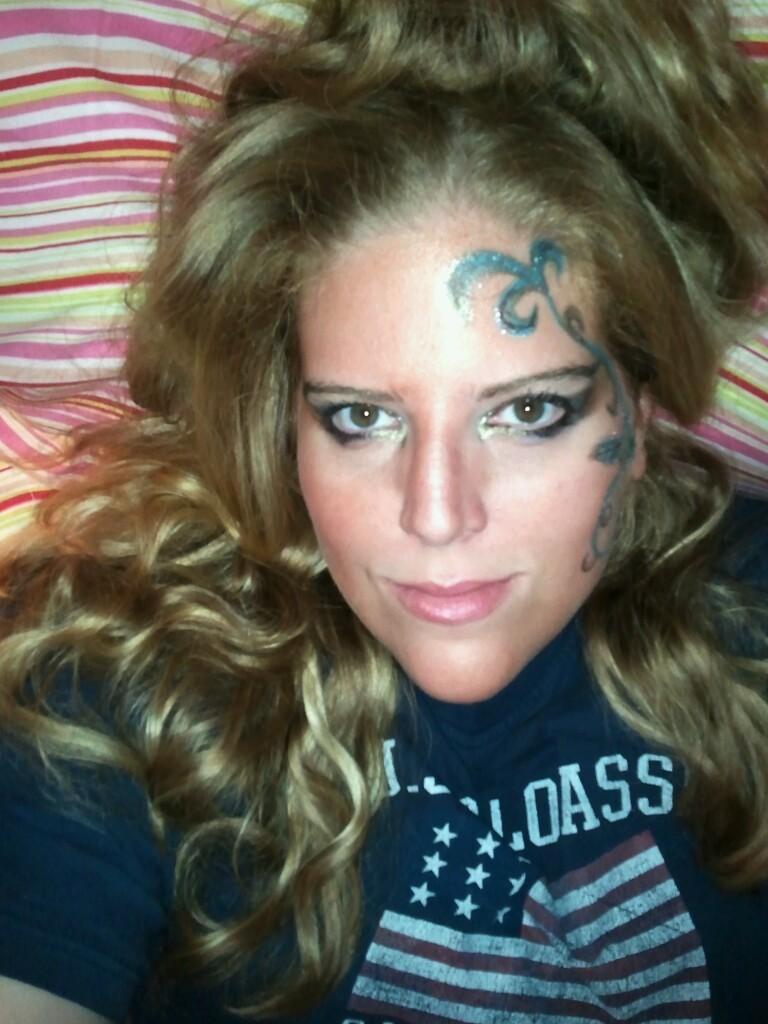In one or two sentences, can you explain what this image depicts? In this image I can see a woman wearing a t-shirt, smiling and looking at the picture. In the background, I can see a cloth. 